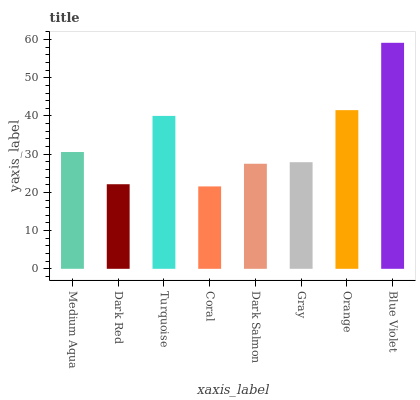Is Coral the minimum?
Answer yes or no. Yes. Is Blue Violet the maximum?
Answer yes or no. Yes. Is Dark Red the minimum?
Answer yes or no. No. Is Dark Red the maximum?
Answer yes or no. No. Is Medium Aqua greater than Dark Red?
Answer yes or no. Yes. Is Dark Red less than Medium Aqua?
Answer yes or no. Yes. Is Dark Red greater than Medium Aqua?
Answer yes or no. No. Is Medium Aqua less than Dark Red?
Answer yes or no. No. Is Medium Aqua the high median?
Answer yes or no. Yes. Is Gray the low median?
Answer yes or no. Yes. Is Turquoise the high median?
Answer yes or no. No. Is Orange the low median?
Answer yes or no. No. 